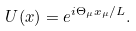Convert formula to latex. <formula><loc_0><loc_0><loc_500><loc_500>U ( x ) = e ^ { i \Theta _ { \mu } x _ { \mu } / L } .</formula> 